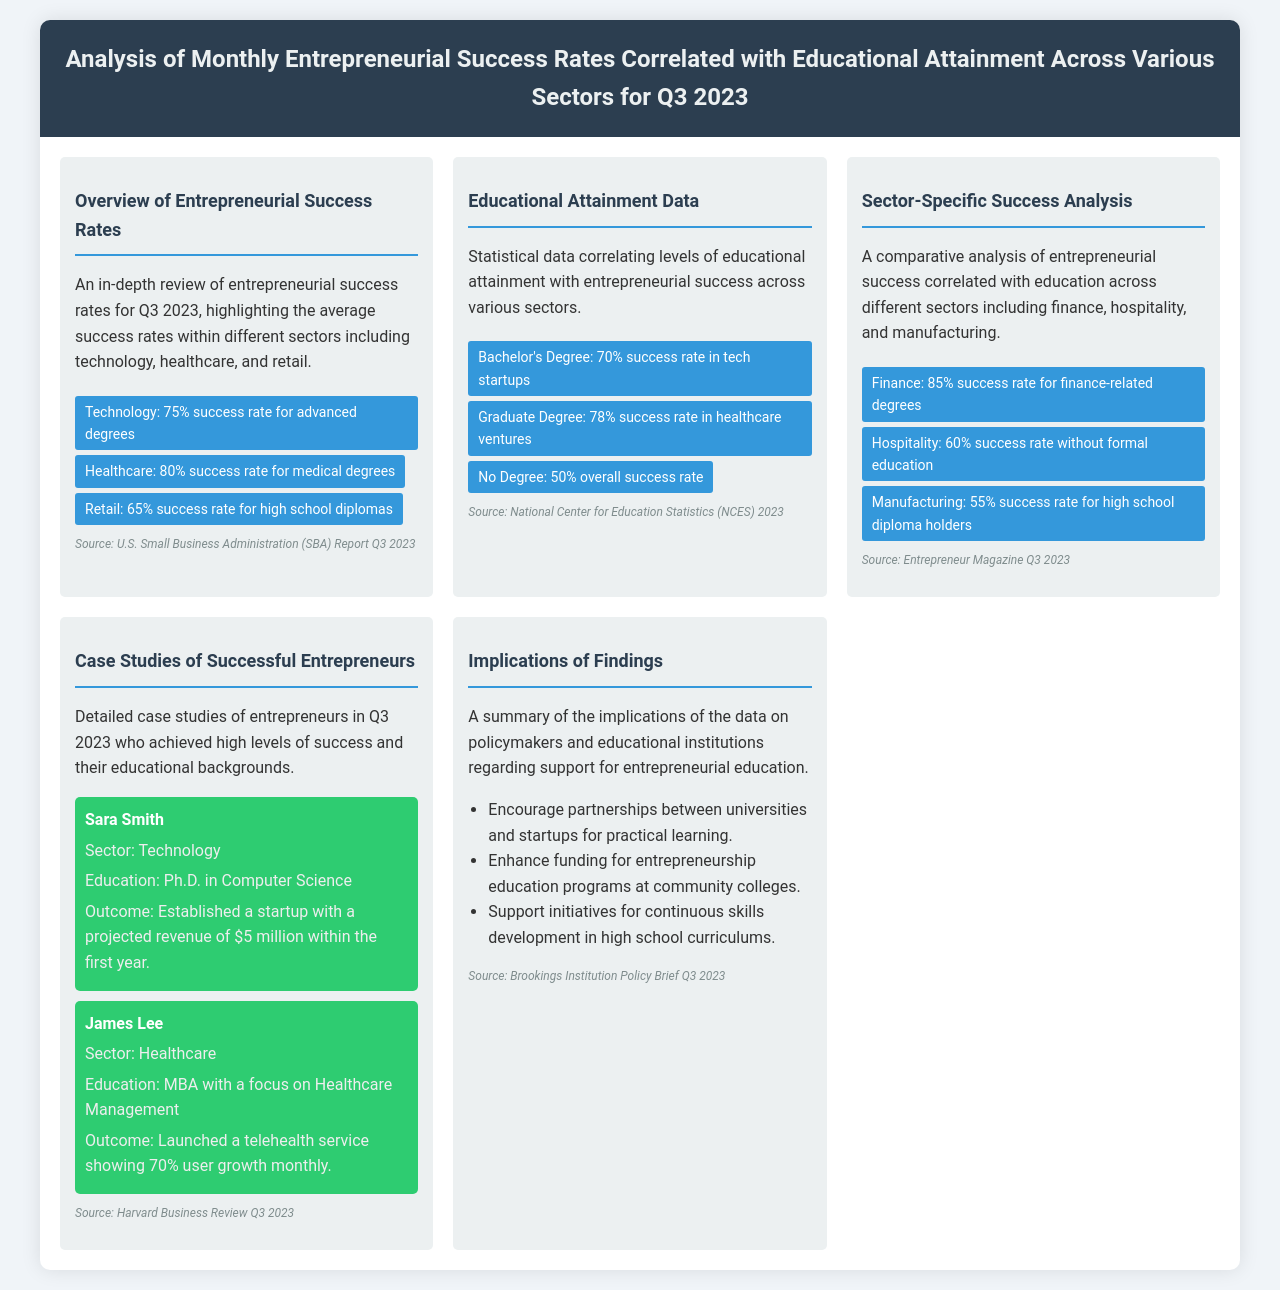What is the average success rate for technology sector entrepreneurs with advanced degrees? The document states the technology sector has a 75% success rate for advanced degrees.
Answer: 75% What educational attainment correlates with a 70% success rate in tech startups? The document specifies that a Bachelor's Degree correlates with a 70% success rate in tech startups.
Answer: Bachelor's Degree What is the success rate for healthcare ventures with graduate degrees? The document indicates the success rate for healthcare ventures with graduate degrees is 78%.
Answer: 78% Which sector has the highest reported success rate for formal education? According to the document, the finance sector has an 85% success rate for finance-related degrees.
Answer: Finance Who is mentioned as a successful entrepreneur in the technology sector? The document names Sara Smith as a successful entrepreneur in the technology sector.
Answer: Sara Smith What is the outcome of James Lee’s telehealth service? The document reports that James Lee's telehealth service shows 70% user growth monthly.
Answer: 70% user growth monthly What is one implication of the findings regarding educational institutions? The document suggests enhancing funding for entrepreneurship education programs at community colleges as an implication.
Answer: Enhance funding Which source provided the data regarding sector-specific success analysis? The document references Entrepreneur Magazine as the source for sector-specific success analysis.
Answer: Entrepreneur Magazine What percentage success rate do retail high school diploma holders experience? The document states that retail high school diploma holders have a 65% success rate.
Answer: 65% 